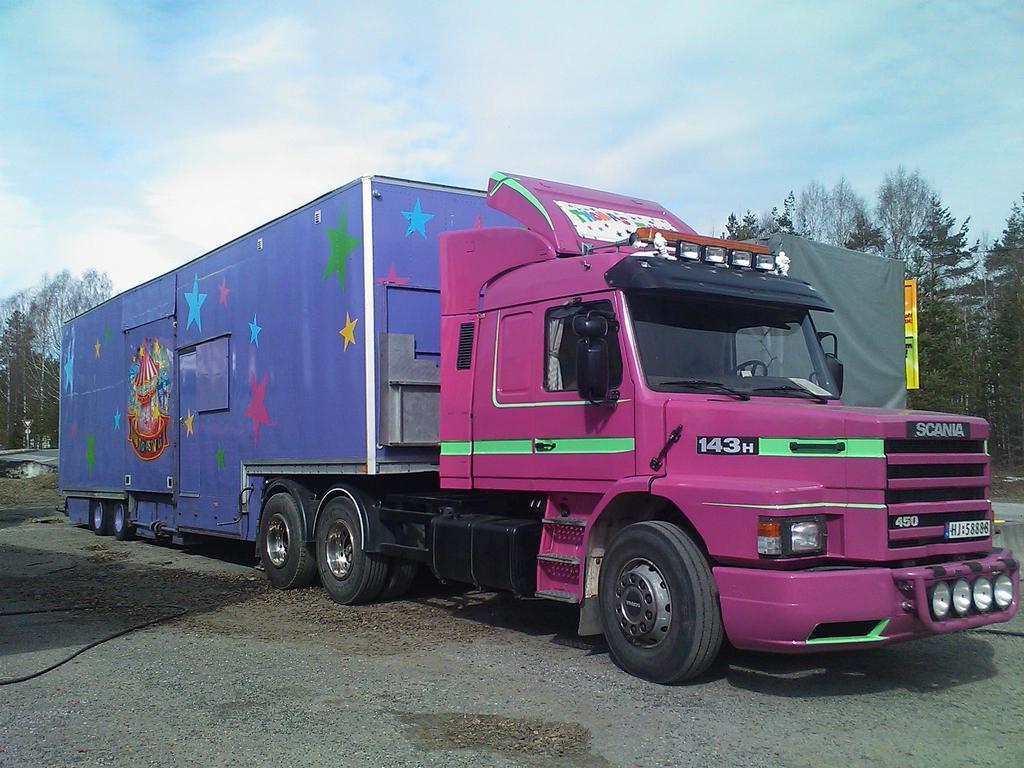Could you give a brief overview of what you see in this image? In this image we can see a vehicle on the road. In the background we can see the trees. At the top there is sky with clouds. 